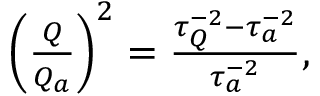Convert formula to latex. <formula><loc_0><loc_0><loc_500><loc_500>\begin{array} { r } { \left ( \frac { Q } { Q _ { a } } \right ) ^ { 2 } = \frac { \tau _ { Q } ^ { - 2 } - \tau _ { a } ^ { - 2 } } { \tau _ { a } ^ { - 2 } } , } \end{array}</formula> 